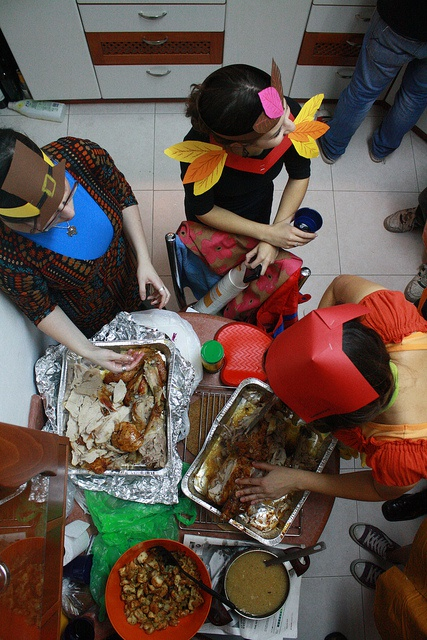Describe the objects in this image and their specific colors. I can see dining table in gray, black, maroon, darkgray, and olive tones, people in gray, black, maroon, darkgray, and brown tones, people in gray, maroon, brown, black, and salmon tones, people in gray, black, darkgray, maroon, and blue tones, and bowl in gray, maroon, black, and olive tones in this image. 